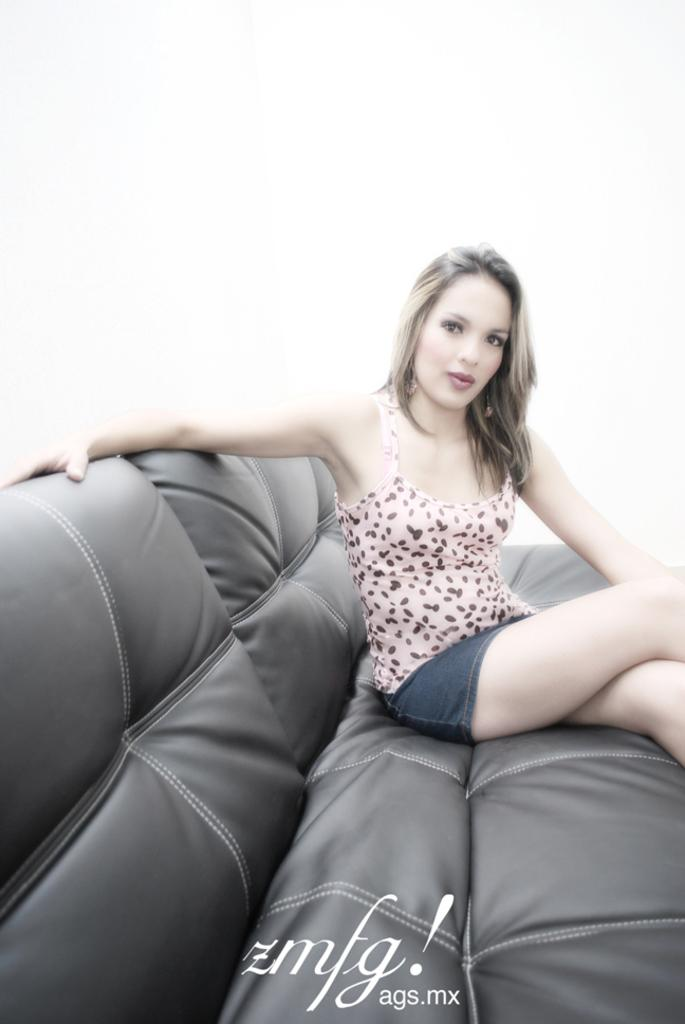Who is the main subject in the image? There is a woman in the image. What is the woman doing in the image? The woman is sitting on a couch. What color is the background of the image? The background of the image is white. What type of badge is the woman wearing in the image? There is no badge visible on the woman in the image. What is the woman's temper like in the image? The image does not provide any information about the woman's temper. 